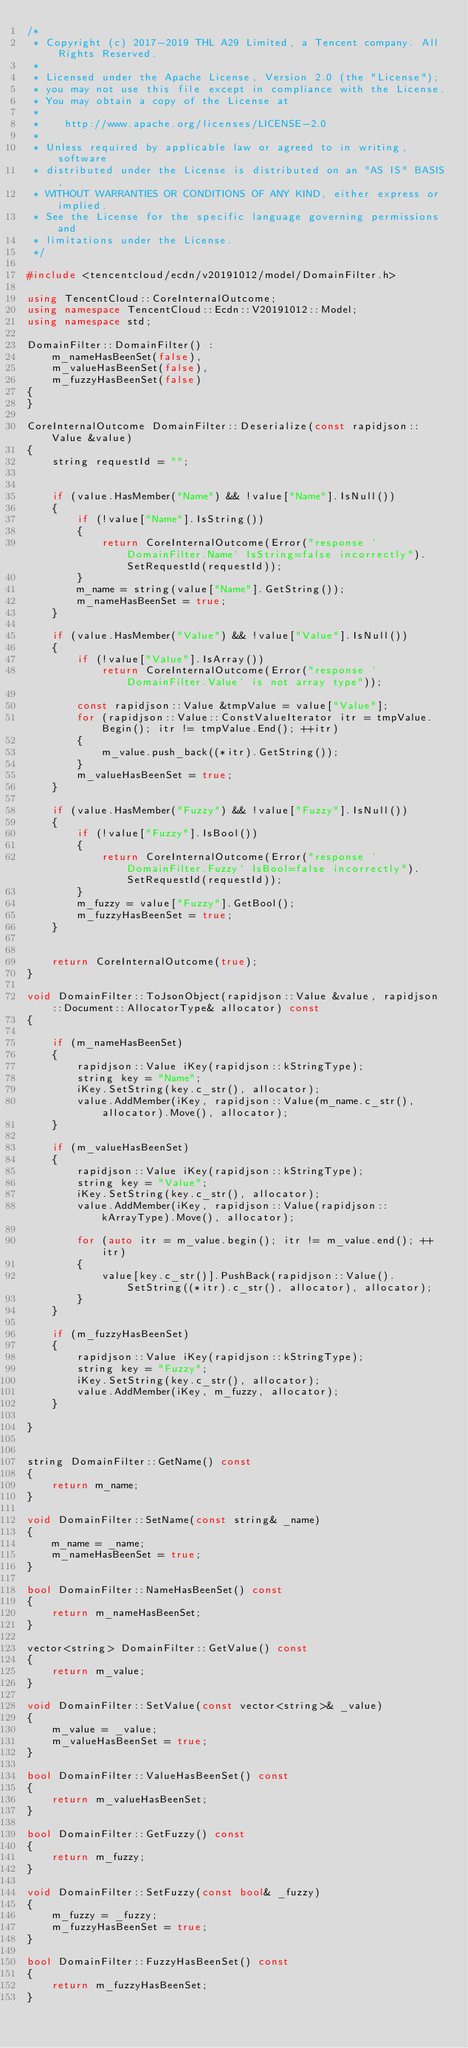<code> <loc_0><loc_0><loc_500><loc_500><_C++_>/*
 * Copyright (c) 2017-2019 THL A29 Limited, a Tencent company. All Rights Reserved.
 *
 * Licensed under the Apache License, Version 2.0 (the "License");
 * you may not use this file except in compliance with the License.
 * You may obtain a copy of the License at
 *
 *    http://www.apache.org/licenses/LICENSE-2.0
 *
 * Unless required by applicable law or agreed to in writing, software
 * distributed under the License is distributed on an "AS IS" BASIS,
 * WITHOUT WARRANTIES OR CONDITIONS OF ANY KIND, either express or implied.
 * See the License for the specific language governing permissions and
 * limitations under the License.
 */

#include <tencentcloud/ecdn/v20191012/model/DomainFilter.h>

using TencentCloud::CoreInternalOutcome;
using namespace TencentCloud::Ecdn::V20191012::Model;
using namespace std;

DomainFilter::DomainFilter() :
    m_nameHasBeenSet(false),
    m_valueHasBeenSet(false),
    m_fuzzyHasBeenSet(false)
{
}

CoreInternalOutcome DomainFilter::Deserialize(const rapidjson::Value &value)
{
    string requestId = "";


    if (value.HasMember("Name") && !value["Name"].IsNull())
    {
        if (!value["Name"].IsString())
        {
            return CoreInternalOutcome(Error("response `DomainFilter.Name` IsString=false incorrectly").SetRequestId(requestId));
        }
        m_name = string(value["Name"].GetString());
        m_nameHasBeenSet = true;
    }

    if (value.HasMember("Value") && !value["Value"].IsNull())
    {
        if (!value["Value"].IsArray())
            return CoreInternalOutcome(Error("response `DomainFilter.Value` is not array type"));

        const rapidjson::Value &tmpValue = value["Value"];
        for (rapidjson::Value::ConstValueIterator itr = tmpValue.Begin(); itr != tmpValue.End(); ++itr)
        {
            m_value.push_back((*itr).GetString());
        }
        m_valueHasBeenSet = true;
    }

    if (value.HasMember("Fuzzy") && !value["Fuzzy"].IsNull())
    {
        if (!value["Fuzzy"].IsBool())
        {
            return CoreInternalOutcome(Error("response `DomainFilter.Fuzzy` IsBool=false incorrectly").SetRequestId(requestId));
        }
        m_fuzzy = value["Fuzzy"].GetBool();
        m_fuzzyHasBeenSet = true;
    }


    return CoreInternalOutcome(true);
}

void DomainFilter::ToJsonObject(rapidjson::Value &value, rapidjson::Document::AllocatorType& allocator) const
{

    if (m_nameHasBeenSet)
    {
        rapidjson::Value iKey(rapidjson::kStringType);
        string key = "Name";
        iKey.SetString(key.c_str(), allocator);
        value.AddMember(iKey, rapidjson::Value(m_name.c_str(), allocator).Move(), allocator);
    }

    if (m_valueHasBeenSet)
    {
        rapidjson::Value iKey(rapidjson::kStringType);
        string key = "Value";
        iKey.SetString(key.c_str(), allocator);
        value.AddMember(iKey, rapidjson::Value(rapidjson::kArrayType).Move(), allocator);

        for (auto itr = m_value.begin(); itr != m_value.end(); ++itr)
        {
            value[key.c_str()].PushBack(rapidjson::Value().SetString((*itr).c_str(), allocator), allocator);
        }
    }

    if (m_fuzzyHasBeenSet)
    {
        rapidjson::Value iKey(rapidjson::kStringType);
        string key = "Fuzzy";
        iKey.SetString(key.c_str(), allocator);
        value.AddMember(iKey, m_fuzzy, allocator);
    }

}


string DomainFilter::GetName() const
{
    return m_name;
}

void DomainFilter::SetName(const string& _name)
{
    m_name = _name;
    m_nameHasBeenSet = true;
}

bool DomainFilter::NameHasBeenSet() const
{
    return m_nameHasBeenSet;
}

vector<string> DomainFilter::GetValue() const
{
    return m_value;
}

void DomainFilter::SetValue(const vector<string>& _value)
{
    m_value = _value;
    m_valueHasBeenSet = true;
}

bool DomainFilter::ValueHasBeenSet() const
{
    return m_valueHasBeenSet;
}

bool DomainFilter::GetFuzzy() const
{
    return m_fuzzy;
}

void DomainFilter::SetFuzzy(const bool& _fuzzy)
{
    m_fuzzy = _fuzzy;
    m_fuzzyHasBeenSet = true;
}

bool DomainFilter::FuzzyHasBeenSet() const
{
    return m_fuzzyHasBeenSet;
}

</code> 